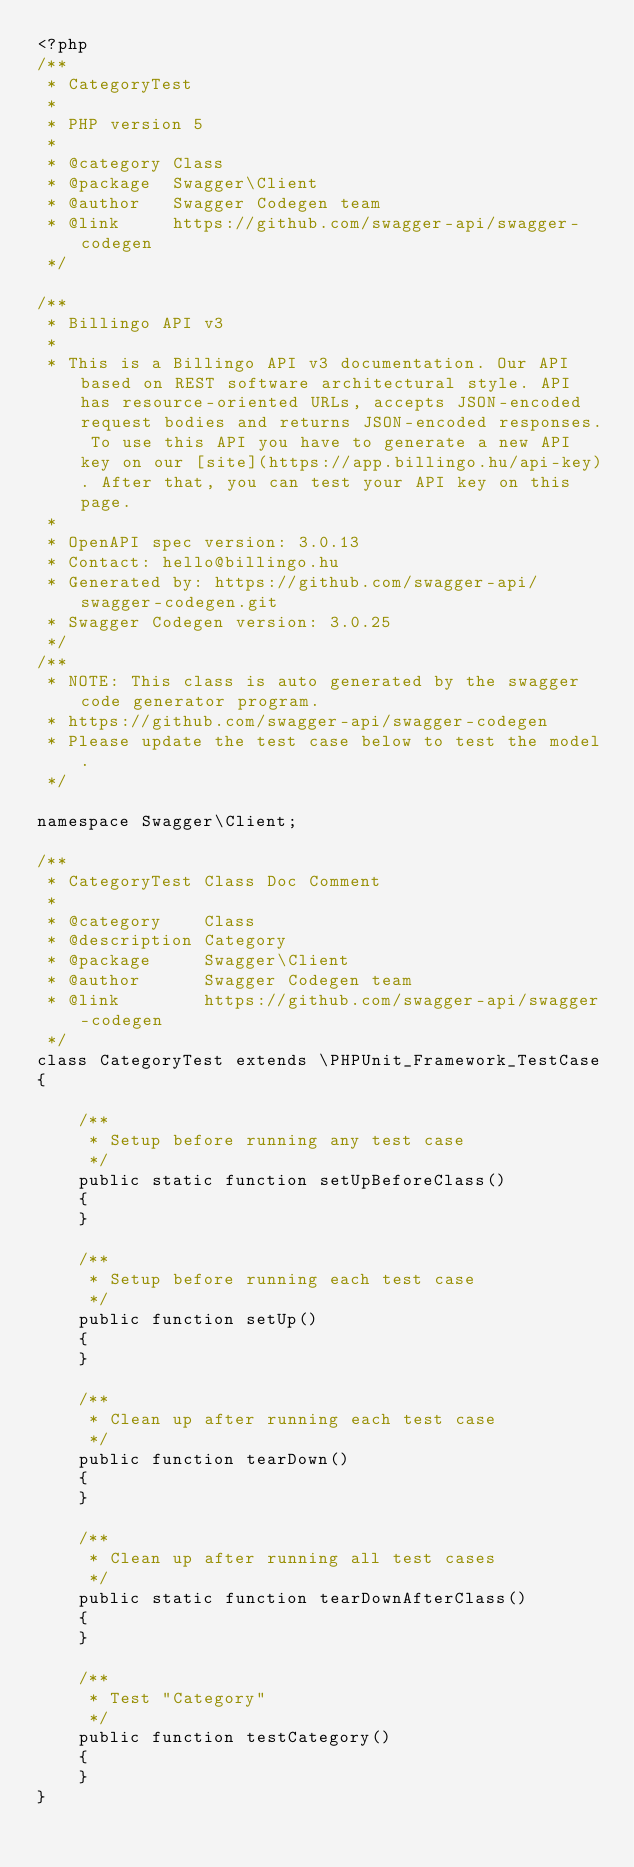<code> <loc_0><loc_0><loc_500><loc_500><_PHP_><?php
/**
 * CategoryTest
 *
 * PHP version 5
 *
 * @category Class
 * @package  Swagger\Client
 * @author   Swagger Codegen team
 * @link     https://github.com/swagger-api/swagger-codegen
 */

/**
 * Billingo API v3
 *
 * This is a Billingo API v3 documentation. Our API based on REST software architectural style. API has resource-oriented URLs, accepts JSON-encoded request bodies and returns JSON-encoded responses. To use this API you have to generate a new API key on our [site](https://app.billingo.hu/api-key). After that, you can test your API key on this page.
 *
 * OpenAPI spec version: 3.0.13
 * Contact: hello@billingo.hu
 * Generated by: https://github.com/swagger-api/swagger-codegen.git
 * Swagger Codegen version: 3.0.25
 */
/**
 * NOTE: This class is auto generated by the swagger code generator program.
 * https://github.com/swagger-api/swagger-codegen
 * Please update the test case below to test the model.
 */

namespace Swagger\Client;

/**
 * CategoryTest Class Doc Comment
 *
 * @category    Class
 * @description Category
 * @package     Swagger\Client
 * @author      Swagger Codegen team
 * @link        https://github.com/swagger-api/swagger-codegen
 */
class CategoryTest extends \PHPUnit_Framework_TestCase
{

    /**
     * Setup before running any test case
     */
    public static function setUpBeforeClass()
    {
    }

    /**
     * Setup before running each test case
     */
    public function setUp()
    {
    }

    /**
     * Clean up after running each test case
     */
    public function tearDown()
    {
    }

    /**
     * Clean up after running all test cases
     */
    public static function tearDownAfterClass()
    {
    }

    /**
     * Test "Category"
     */
    public function testCategory()
    {
    }
}
</code> 